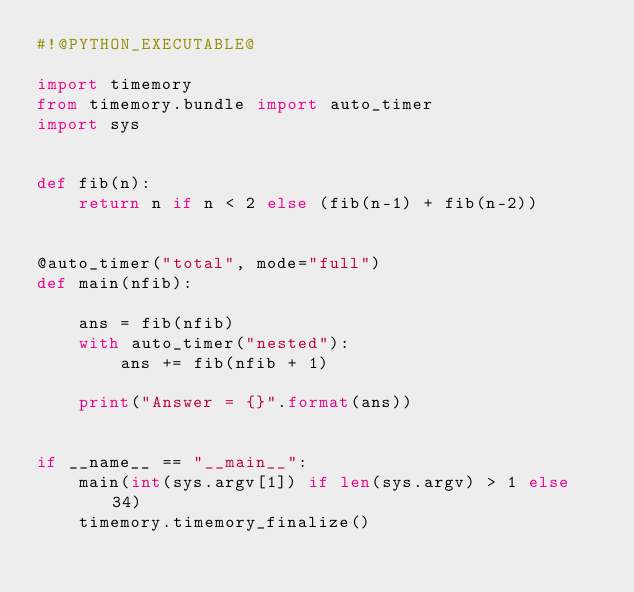<code> <loc_0><loc_0><loc_500><loc_500><_Python_>#!@PYTHON_EXECUTABLE@

import timemory
from timemory.bundle import auto_timer
import sys


def fib(n):
    return n if n < 2 else (fib(n-1) + fib(n-2))


@auto_timer("total", mode="full")
def main(nfib):

    ans = fib(nfib)
    with auto_timer("nested"):
        ans += fib(nfib + 1)

    print("Answer = {}".format(ans))


if __name__ == "__main__":
    main(int(sys.argv[1]) if len(sys.argv) > 1 else 34)
    timemory.timemory_finalize()
</code> 